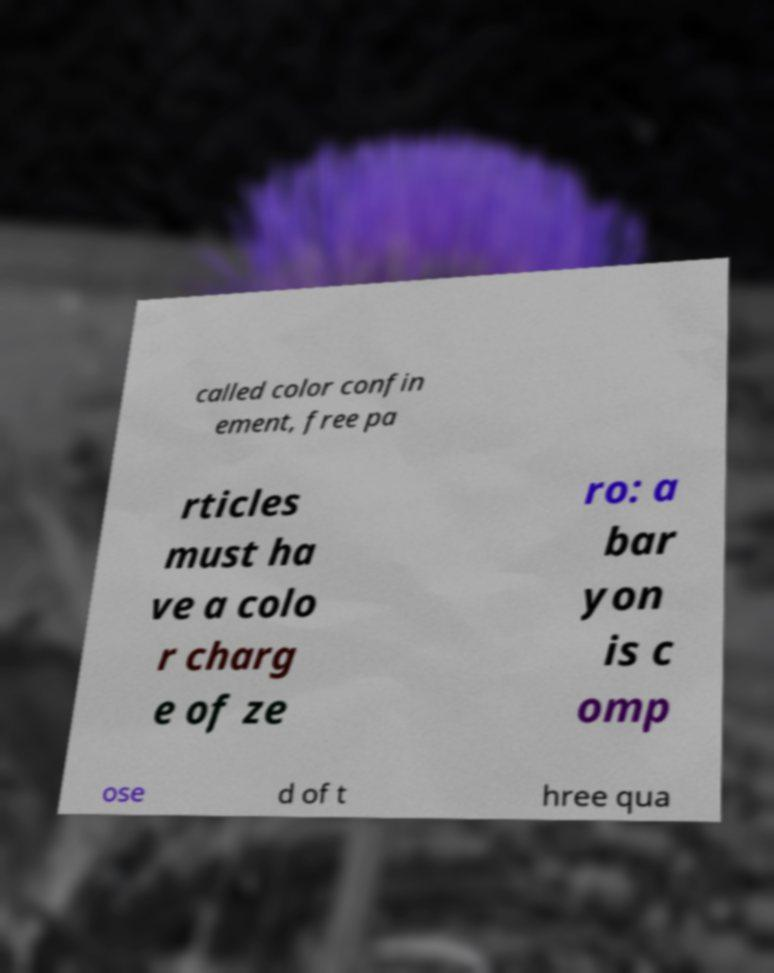Could you assist in decoding the text presented in this image and type it out clearly? called color confin ement, free pa rticles must ha ve a colo r charg e of ze ro: a bar yon is c omp ose d of t hree qua 